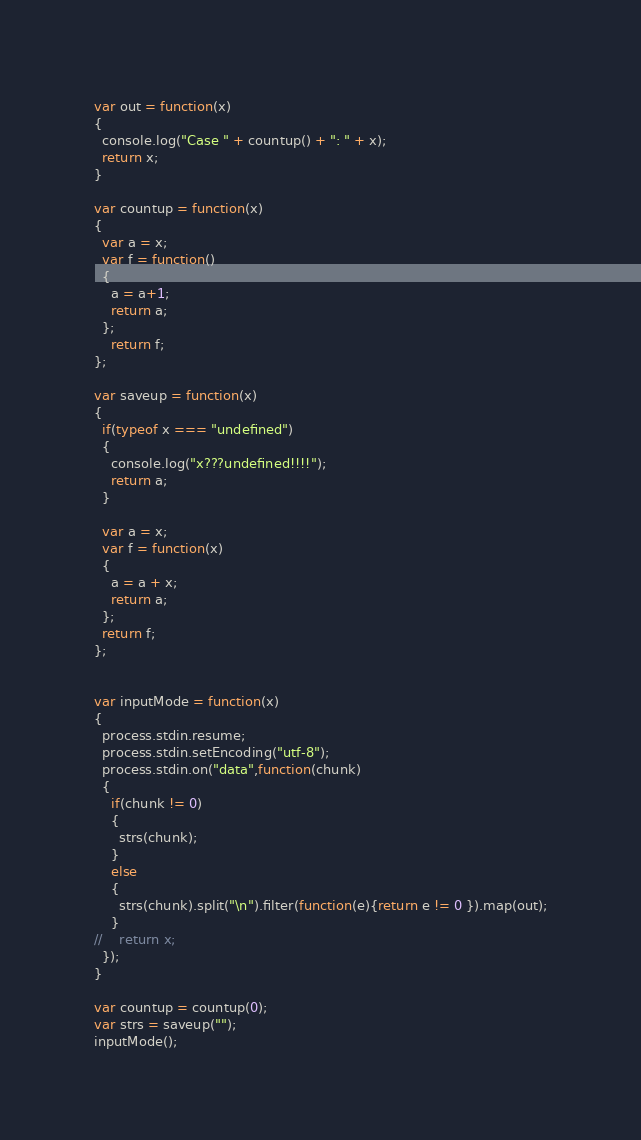<code> <loc_0><loc_0><loc_500><loc_500><_JavaScript_>var out = function(x)
{
  console.log("Case " + countup() + ": " + x);
  return x;
}

var countup = function(x)
{
  var a = x;
  var f = function()
  {
    a = a+1;
    return a;
  };
    return f;
};

var saveup = function(x)
{
  if(typeof x === "undefined")
  {
    console.log("x???undefined!!!!");
    return a;
  }

  var a = x;
  var f = function(x)
  {
    a = a + x;
    return a;
  };
  return f;
};


var inputMode = function(x)
{
  process.stdin.resume;
  process.stdin.setEncoding("utf-8");
  process.stdin.on("data",function(chunk)
  {
    if(chunk != 0)
    {
      strs(chunk);
    }
    else
    {
      strs(chunk).split("\n").filter(function(e){return e != 0 }).map(out);
    }
//    return x;
  });
}

var countup = countup(0);
var strs = saveup("");
inputMode();</code> 